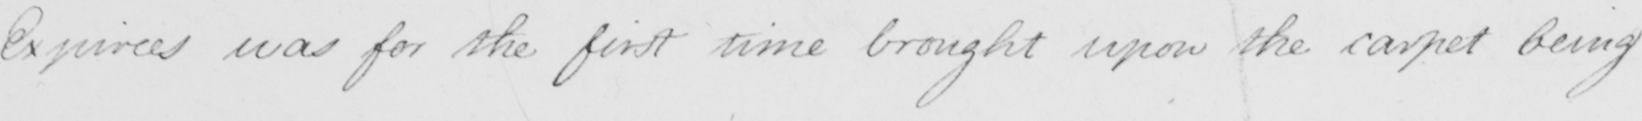Can you read and transcribe this handwriting? Expirees was for the first time brought upon the carpet being 